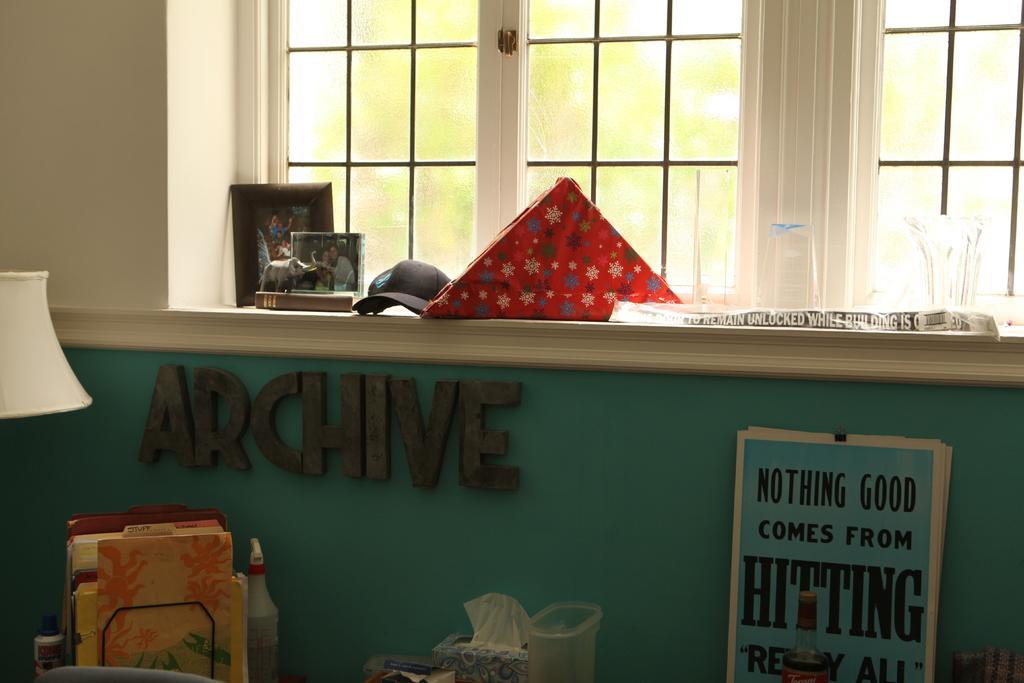How would you summarize this image in a sentence or two? In this picture I can see a plastic spray bottle , tissues box, plastic box, papers, bottle, paper clip with papers in a stand, lamp, photo frames, toy elephant, hat ,glasses and some other items, and in the background there is a window and a wall. 